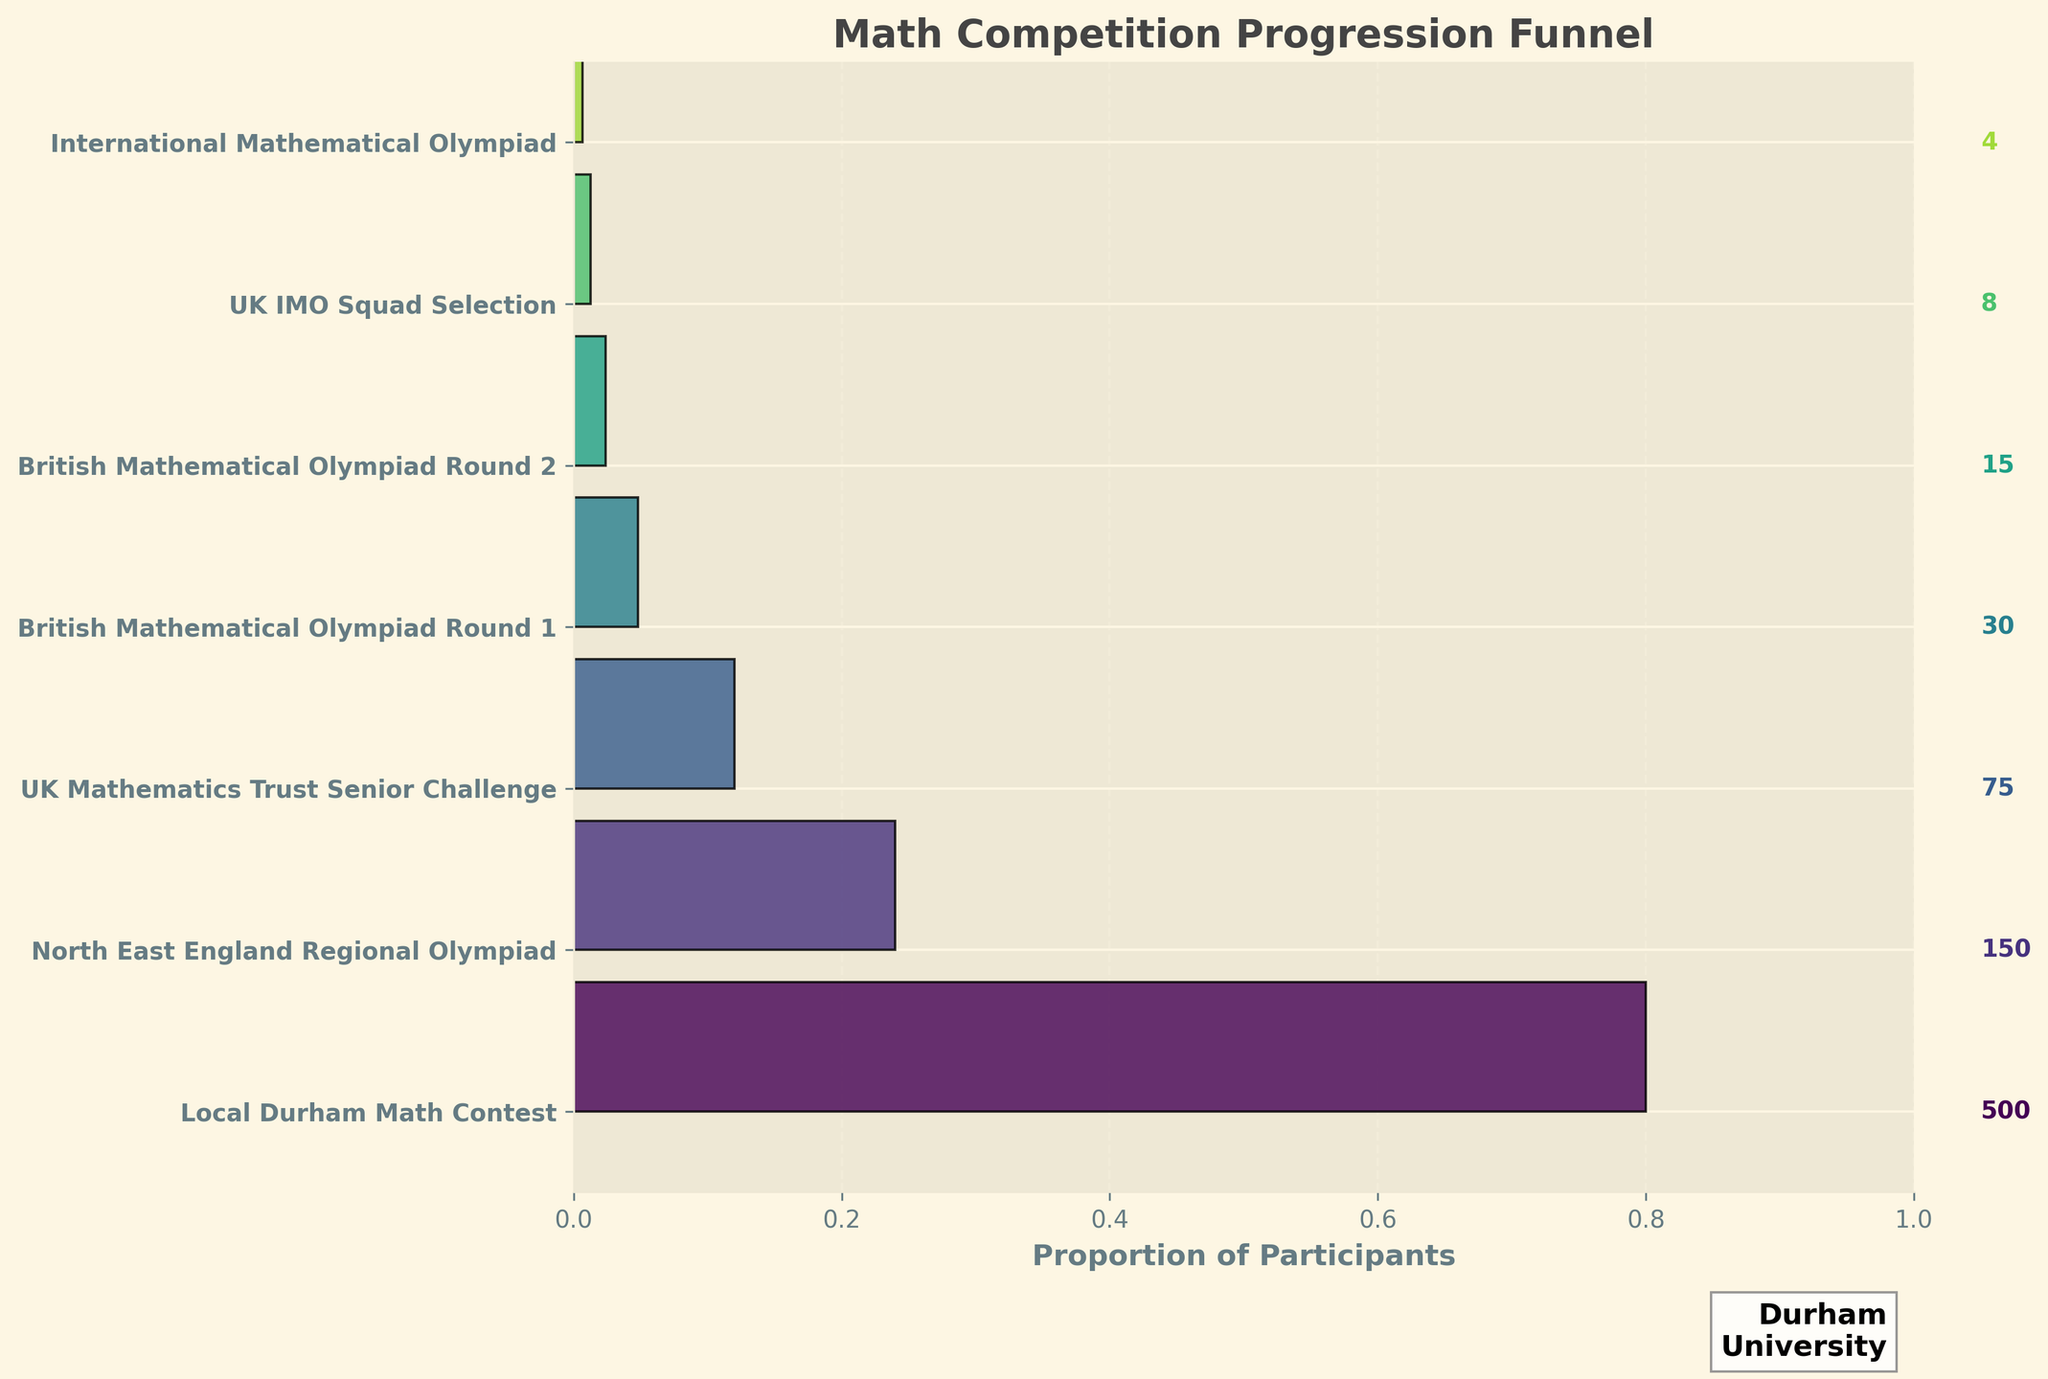What is the title of the plot? The title is usually located at the top of the figure, it's clearly labeled to give an idea about the content. The title in this figure is "Math Competition Progression Funnel".
Answer: Math Competition Progression Funnel How many stages are shown in the funnel chart? Count the number of different stages listed along the y-axis. Each stage represents a different level of the math competition.
Answer: 6 stages Which stage had the highest number of participants? The highest number of participants can be identified by looking at the widest segment at the top of the funnel. The stage with the largest number of participants is the "Local Durham Math Contest" with 500 participants.
Answer: Local Durham Math Contest How many participants advanced from the "UK Mathematics Trust Senior Challenge" to "British Mathematical Olympiad Round 1"? To find the number of participants advancing from one stage to the next, subtract the participants in "British Mathematical Olympiad Round 1" from those in "UK Mathematics Trust Senior Challenge". This requires the subtraction (75 - 30).
Answer: 45 What is the difference in participant numbers between the "British Mathematical Olympiad Round 2" and the "UK IMO Squad Selection"? The number of participants in the "British Mathematical Olympiad Round 2" is 15 and the number in the "UK IMO Squad Selection" is 8. Subtract 8 from 15 (15 - 8).
Answer: 7 How many participants decreased each stage on average from "Local Durham Math Contest" to "International Mathematical Olympiad"? Calculate the average decrease by summing the number of participants at each stage, then dividing by the number of stages minus one (since decreases are between stages). Total participants are 500 + 150 + 75 + 30 + 15 + 8 + 4 = 782. Subtract the first number (500) and the last number (4) from the total sum of decreases (500 - 150) + (150 - 75) + (75 - 30) + (30 - 15) + (15 - 8) + (8 - 4) and divide by 6 stages.
Answer: Average decrease of 82.67 participants per stage Which two consecutive stages had the largest drop in participants? Compare the participant difference between each consecutive stage. The largest drop is the difference between "Local Durham Math Contest" and "North East England Regional Olympiad" (500 - 150 = 350).
Answer: Local Durham Math Contest and North East England Regional Olympiad How many participants were there in total across all stages? Add the number of participants in each stage: 500 + 150 + 75 + 30 + 15 + 8 + 4.
Answer: 782 Which stage has the smallest number of participants? The stage with the smallest segment or lowest value in the table is the "International Mathematical Olympiad" with 4 participants.
Answer: International Mathematical Olympiad 